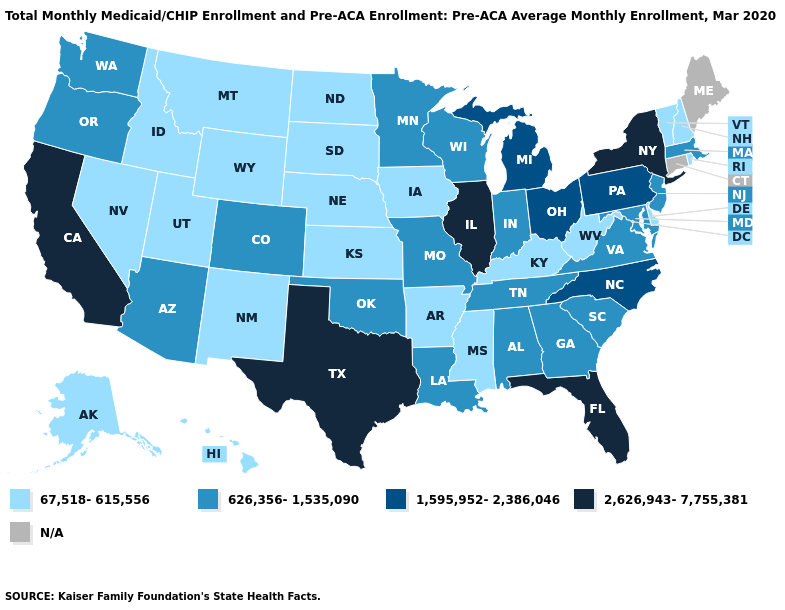What is the value of New Hampshire?
Short answer required. 67,518-615,556. Does the map have missing data?
Short answer required. Yes. What is the value of Arizona?
Quick response, please. 626,356-1,535,090. Name the states that have a value in the range 626,356-1,535,090?
Concise answer only. Alabama, Arizona, Colorado, Georgia, Indiana, Louisiana, Maryland, Massachusetts, Minnesota, Missouri, New Jersey, Oklahoma, Oregon, South Carolina, Tennessee, Virginia, Washington, Wisconsin. Name the states that have a value in the range 67,518-615,556?
Keep it brief. Alaska, Arkansas, Delaware, Hawaii, Idaho, Iowa, Kansas, Kentucky, Mississippi, Montana, Nebraska, Nevada, New Hampshire, New Mexico, North Dakota, Rhode Island, South Dakota, Utah, Vermont, West Virginia, Wyoming. Name the states that have a value in the range 67,518-615,556?
Quick response, please. Alaska, Arkansas, Delaware, Hawaii, Idaho, Iowa, Kansas, Kentucky, Mississippi, Montana, Nebraska, Nevada, New Hampshire, New Mexico, North Dakota, Rhode Island, South Dakota, Utah, Vermont, West Virginia, Wyoming. What is the value of Utah?
Answer briefly. 67,518-615,556. What is the value of Florida?
Concise answer only. 2,626,943-7,755,381. What is the lowest value in the USA?
Short answer required. 67,518-615,556. What is the lowest value in the West?
Give a very brief answer. 67,518-615,556. What is the highest value in states that border Arkansas?
Give a very brief answer. 2,626,943-7,755,381. What is the highest value in the USA?
Concise answer only. 2,626,943-7,755,381. What is the value of Alabama?
Quick response, please. 626,356-1,535,090. Which states hav the highest value in the MidWest?
Give a very brief answer. Illinois. 